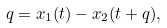Convert formula to latex. <formula><loc_0><loc_0><loc_500><loc_500>q = x _ { 1 } ( t ) - x _ { 2 } ( t + q ) ,</formula> 